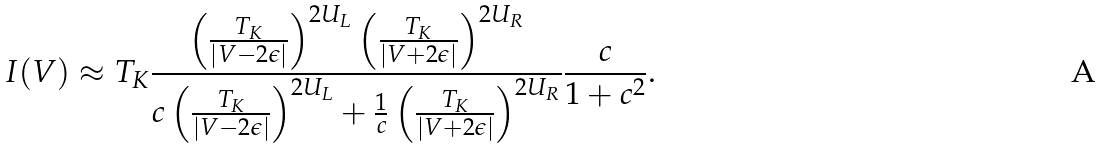Convert formula to latex. <formula><loc_0><loc_0><loc_500><loc_500>I ( V ) \approx T _ { K } \frac { \left ( \frac { T _ { K } } { | V - 2 \epsilon | } \right ) ^ { 2 U _ { L } } \left ( \frac { T _ { K } } { | V + 2 \epsilon | } \right ) ^ { 2 U _ { R } } } { c \left ( \frac { T _ { K } } { | V - 2 \epsilon | } \right ) ^ { 2 U _ { L } } + \frac { 1 } { c } \left ( \frac { T _ { K } } { | V + 2 \epsilon | } \right ) ^ { 2 U _ { R } } } \frac { c } { 1 + c ^ { 2 } } .</formula> 